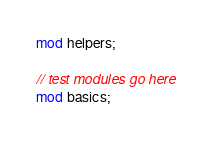<code> <loc_0><loc_0><loc_500><loc_500><_Rust_>mod helpers;

// test modules go here
mod basics;
</code> 